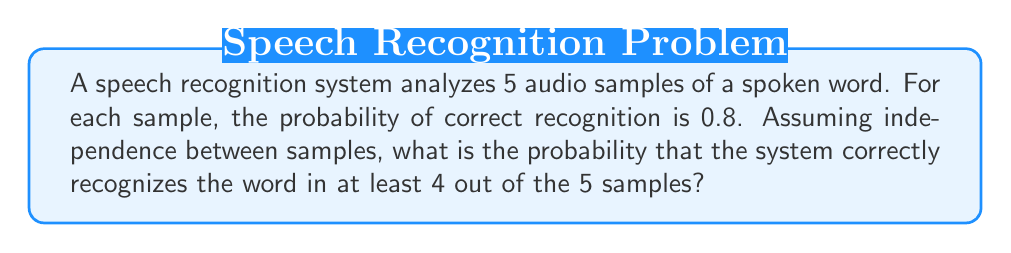Provide a solution to this math problem. Let's approach this step-by-step:

1) First, we need to identify that this is a binomial probability problem. We have:
   - n = 5 trials (audio samples)
   - p = 0.8 probability of success (correct recognition) for each trial
   - We want at least 4 successes

2) We need to calculate P(X ≥ 4), where X is the number of successful recognitions.

3) This probability is the sum of P(X = 4) and P(X = 5):
   P(X ≥ 4) = P(X = 4) + P(X = 5)

4) We can calculate these using the binomial probability formula:
   $$P(X = k) = \binom{n}{k} p^k (1-p)^{n-k}$$

5) For P(X = 4):
   $$P(X = 4) = \binom{5}{4} (0.8)^4 (0.2)^1 = 5 \cdot 0.4096 \cdot 0.2 = 0.4096$$

6) For P(X = 5):
   $$P(X = 5) = \binom{5}{5} (0.8)^5 (0.2)^0 = 1 \cdot 0.32768 \cdot 1 = 0.32768$$

7) Therefore, the total probability is:
   P(X ≥ 4) = 0.4096 + 0.32768 = 0.73728
Answer: 0.73728 